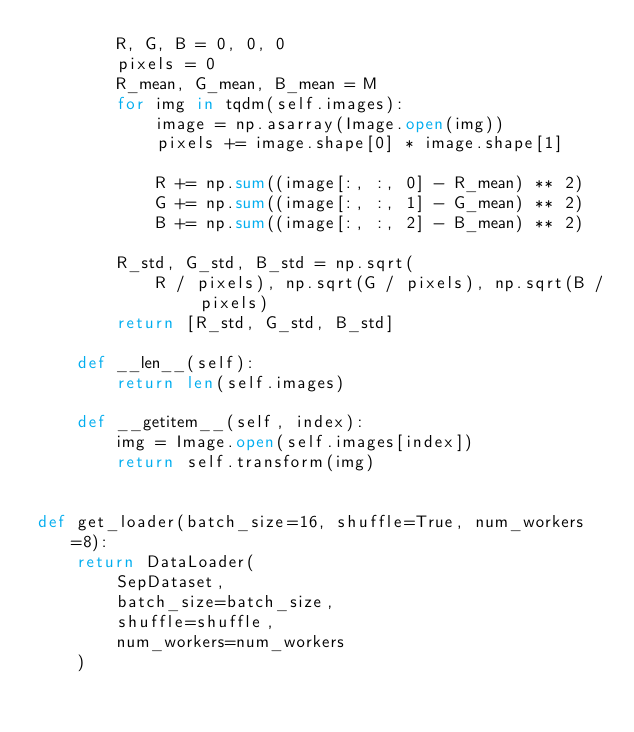Convert code to text. <code><loc_0><loc_0><loc_500><loc_500><_Python_>        R, G, B = 0, 0, 0
        pixels = 0
        R_mean, G_mean, B_mean = M
        for img in tqdm(self.images):
            image = np.asarray(Image.open(img))
            pixels += image.shape[0] * image.shape[1]

            R += np.sum((image[:, :, 0] - R_mean) ** 2)
            G += np.sum((image[:, :, 1] - G_mean) ** 2)
            B += np.sum((image[:, :, 2] - B_mean) ** 2)

        R_std, G_std, B_std = np.sqrt(
            R / pixels), np.sqrt(G / pixels), np.sqrt(B / pixels)
        return [R_std, G_std, B_std]

    def __len__(self):
        return len(self.images)

    def __getitem__(self, index):
        img = Image.open(self.images[index])
        return self.transform(img)


def get_loader(batch_size=16, shuffle=True, num_workers=8):
    return DataLoader(
        SepDataset,
        batch_size=batch_size,
        shuffle=shuffle,
        num_workers=num_workers
    )
</code> 